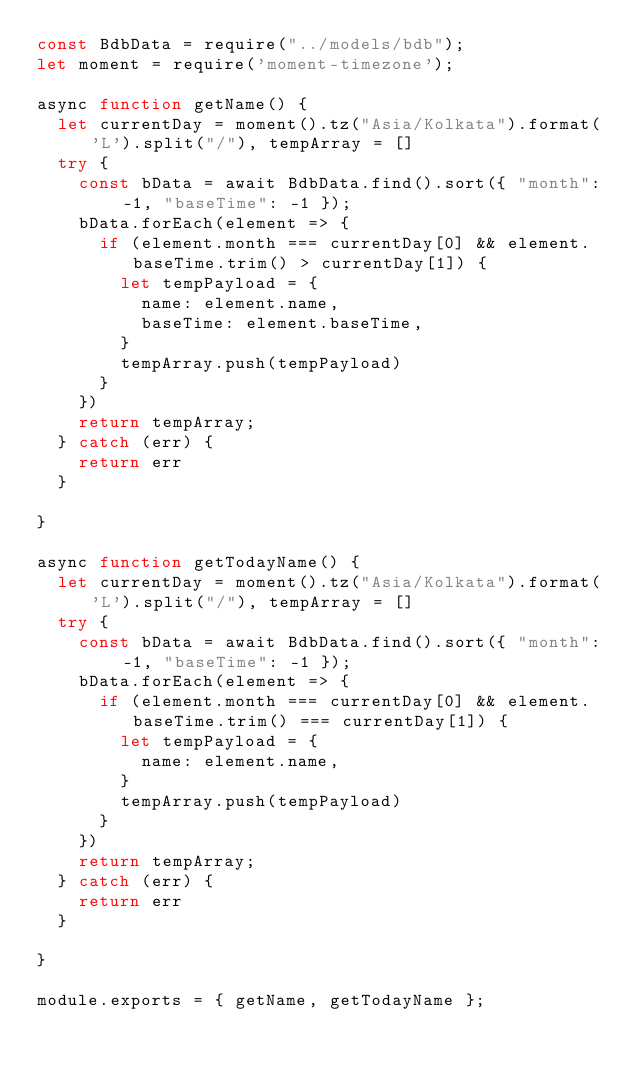<code> <loc_0><loc_0><loc_500><loc_500><_JavaScript_>const BdbData = require("../models/bdb");
let moment = require('moment-timezone');

async function getName() {
  let currentDay = moment().tz("Asia/Kolkata").format('L').split("/"), tempArray = []
  try {
    const bData = await BdbData.find().sort({ "month": -1, "baseTime": -1 });
    bData.forEach(element => {
      if (element.month === currentDay[0] && element.baseTime.trim() > currentDay[1]) {
        let tempPayload = {
          name: element.name,
          baseTime: element.baseTime,
        }
        tempArray.push(tempPayload)
      }
    })
    return tempArray;
  } catch (err) {
    return err
  }

}

async function getTodayName() {
  let currentDay = moment().tz("Asia/Kolkata").format('L').split("/"), tempArray = []
  try {
    const bData = await BdbData.find().sort({ "month": -1, "baseTime": -1 });
    bData.forEach(element => {
      if (element.month === currentDay[0] && element.baseTime.trim() === currentDay[1]) {
        let tempPayload = {
          name: element.name,
        }
        tempArray.push(tempPayload)
      }
    })
    return tempArray;
  } catch (err) {
    return err
  }

}

module.exports = { getName, getTodayName };</code> 